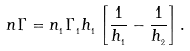Convert formula to latex. <formula><loc_0><loc_0><loc_500><loc_500>n \Gamma = n _ { _ { 1 } } \Gamma _ { _ { 1 } } h _ { _ { 1 } } \left [ \frac { 1 } { h _ { _ { 1 } } } - \frac { 1 } { h _ { _ { 2 } } } \right ] { . }</formula> 